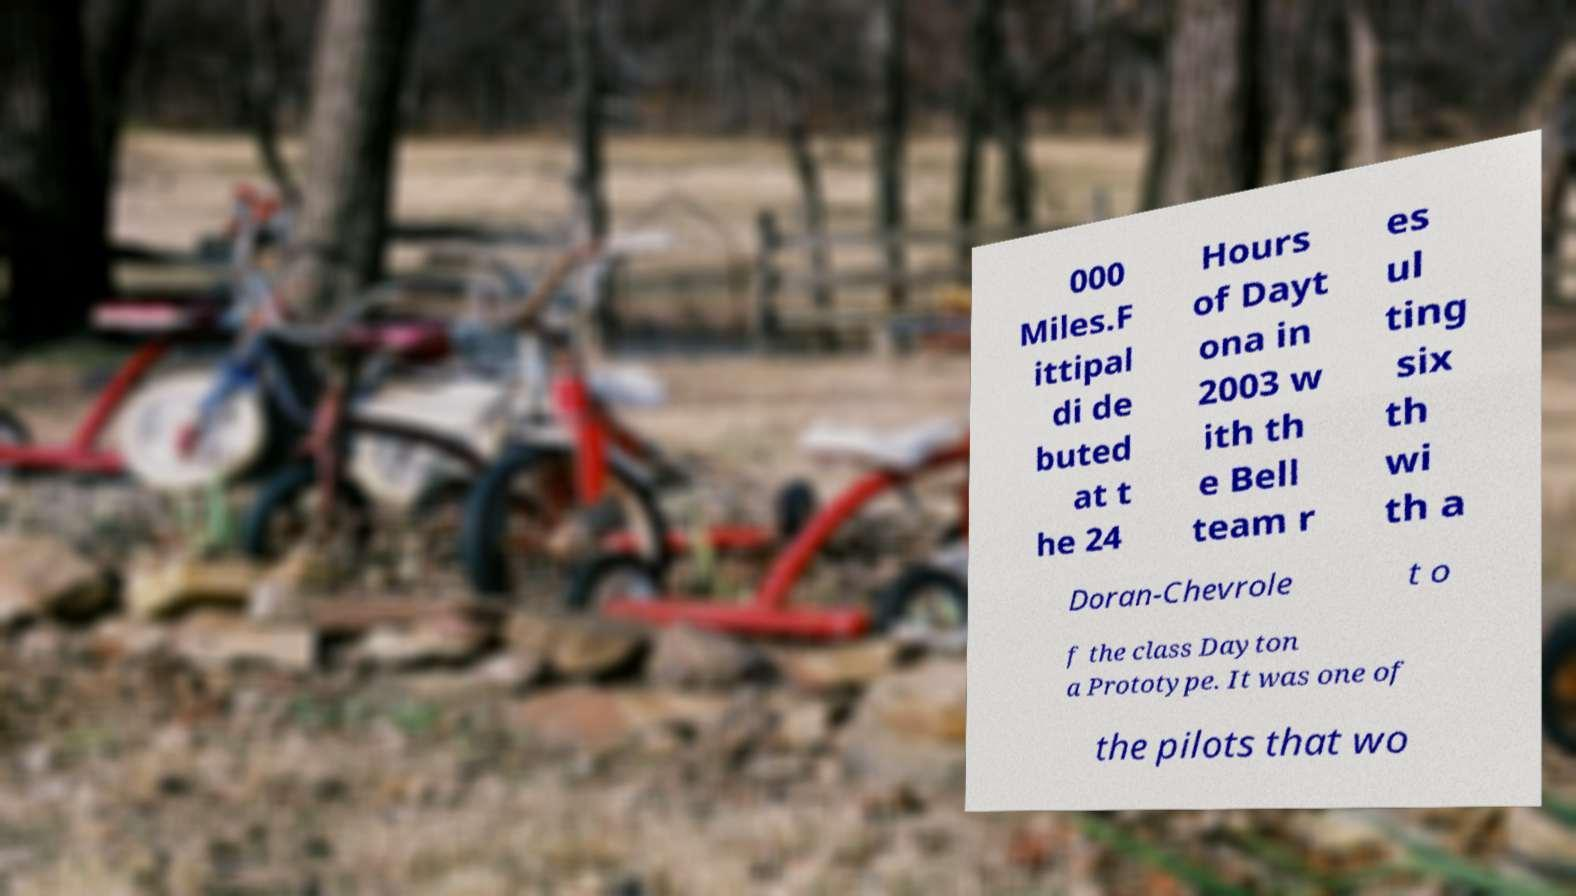Please read and relay the text visible in this image. What does it say? 000 Miles.F ittipal di de buted at t he 24 Hours of Dayt ona in 2003 w ith th e Bell team r es ul ting six th wi th a Doran-Chevrole t o f the class Dayton a Prototype. It was one of the pilots that wo 